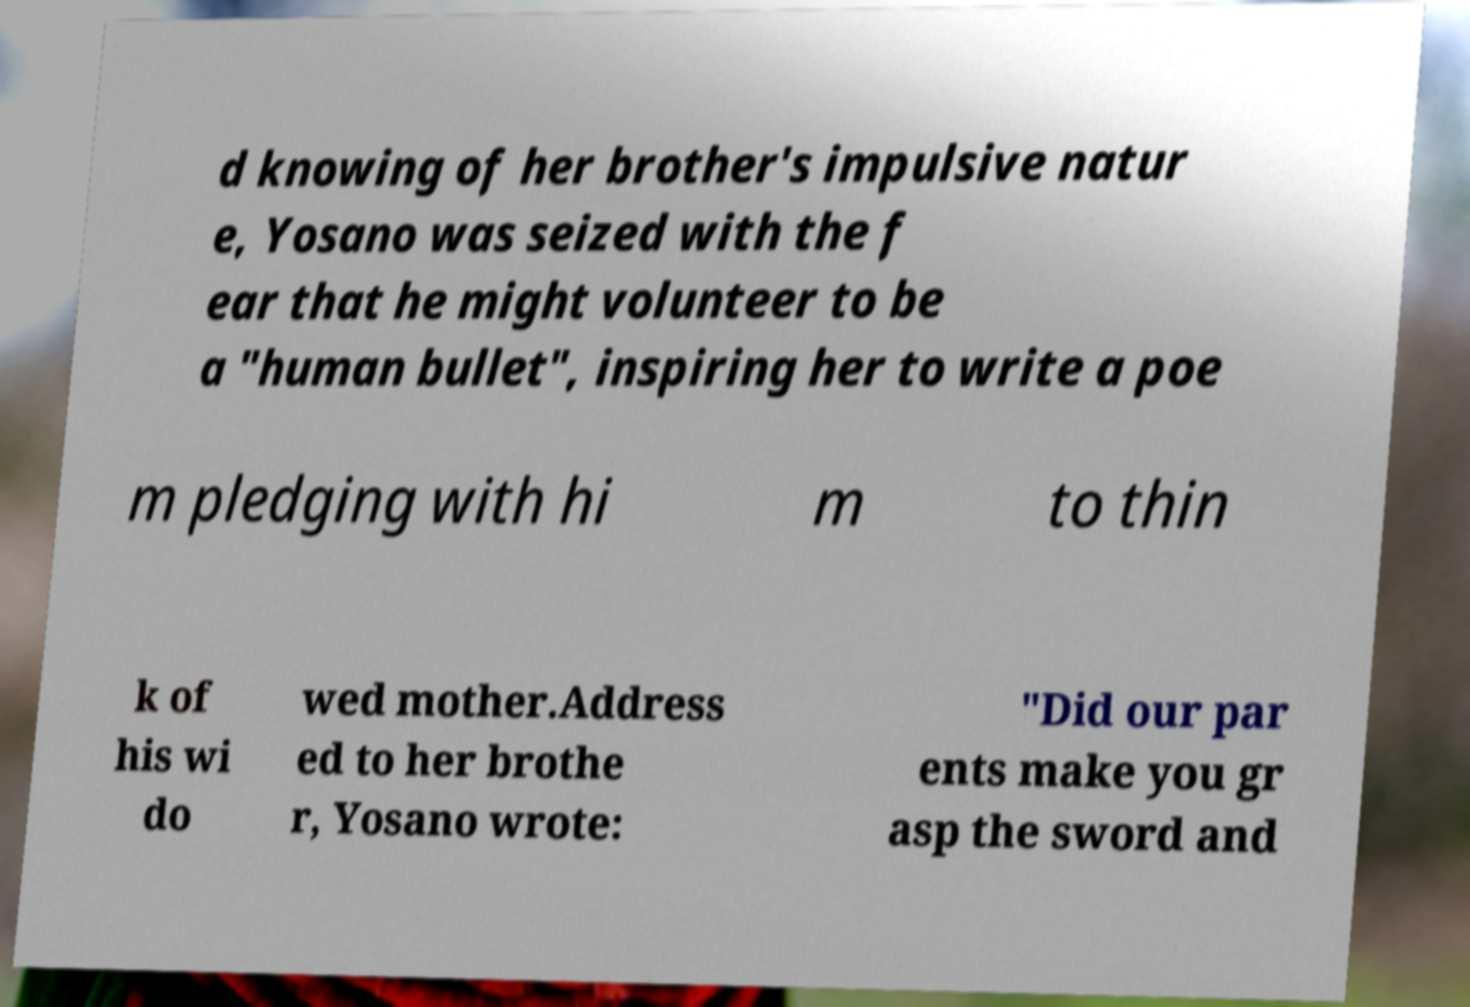Could you extract and type out the text from this image? d knowing of her brother's impulsive natur e, Yosano was seized with the f ear that he might volunteer to be a "human bullet", inspiring her to write a poe m pledging with hi m to thin k of his wi do wed mother.Address ed to her brothe r, Yosano wrote: "Did our par ents make you gr asp the sword and 